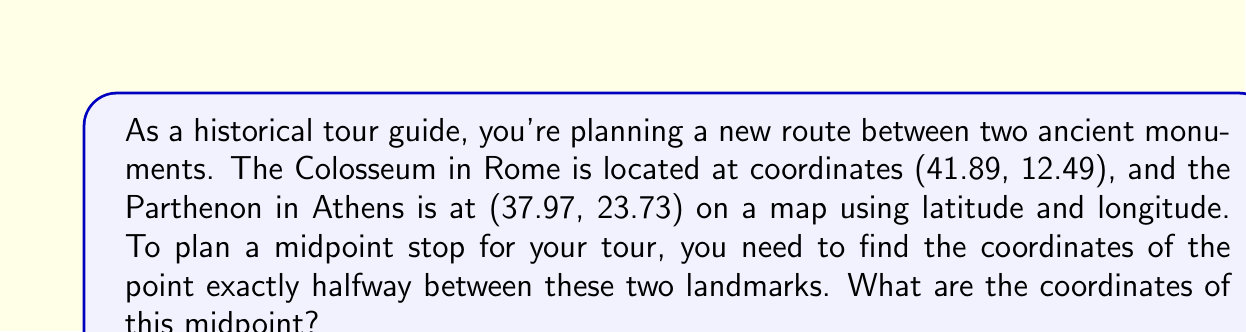Help me with this question. To find the midpoint between two points in a coordinate system, we use the midpoint formula:

$$\text{Midpoint} = \left(\frac{x_1 + x_2}{2}, \frac{y_1 + y_2}{2}\right)$$

Where $(x_1, y_1)$ are the coordinates of the first point and $(x_2, y_2)$ are the coordinates of the second point.

In this case:
- Colosseum: $(x_1, y_1) = (41.89, 12.49)$
- Parthenon: $(x_2, y_2) = (37.97, 23.73)$

Let's calculate the midpoint:

1. For the x-coordinate (latitude):
   $$\frac{x_1 + x_2}{2} = \frac{41.89 + 37.97}{2} = \frac{79.86}{2} = 39.93$$

2. For the y-coordinate (longitude):
   $$\frac{y_1 + y_2}{2} = \frac{12.49 + 23.73}{2} = \frac{36.22}{2} = 18.11$$

Therefore, the midpoint coordinates are (39.93, 18.11).

[asy]
unitsize(10cm);
pair Colosseum = (41.89, 12.49);
pair Parthenon = (37.97, 23.73);
pair Midpoint = (39.93, 18.11);

draw((35,10)--(45,25), gray);
draw((35,25)--(45,10), gray);

dot(Colosseum, red);
dot(Parthenon, blue);
dot(Midpoint, green);

label("Colosseum (41.89, 12.49)", Colosseum, SW, red);
label("Parthenon (37.97, 23.73)", Parthenon, NE, blue);
label("Midpoint (39.93, 18.11)", Midpoint, SE, green);
[/asy]
Answer: The coordinates of the midpoint between the Colosseum and the Parthenon are (39.93, 18.11). 